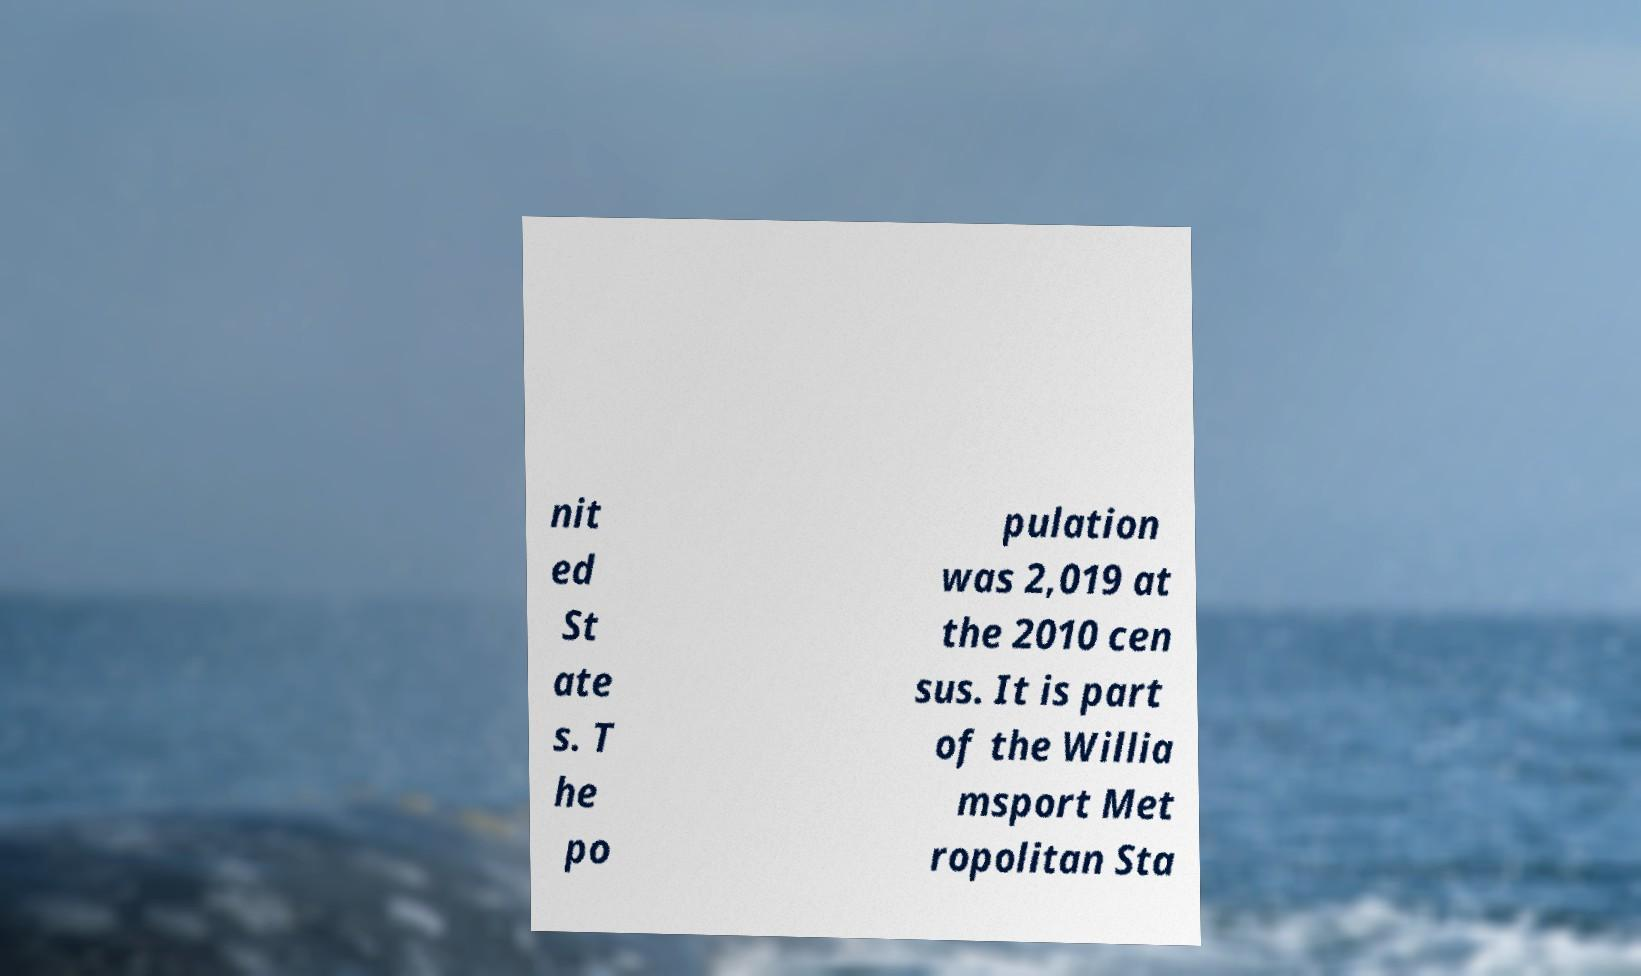There's text embedded in this image that I need extracted. Can you transcribe it verbatim? nit ed St ate s. T he po pulation was 2,019 at the 2010 cen sus. It is part of the Willia msport Met ropolitan Sta 